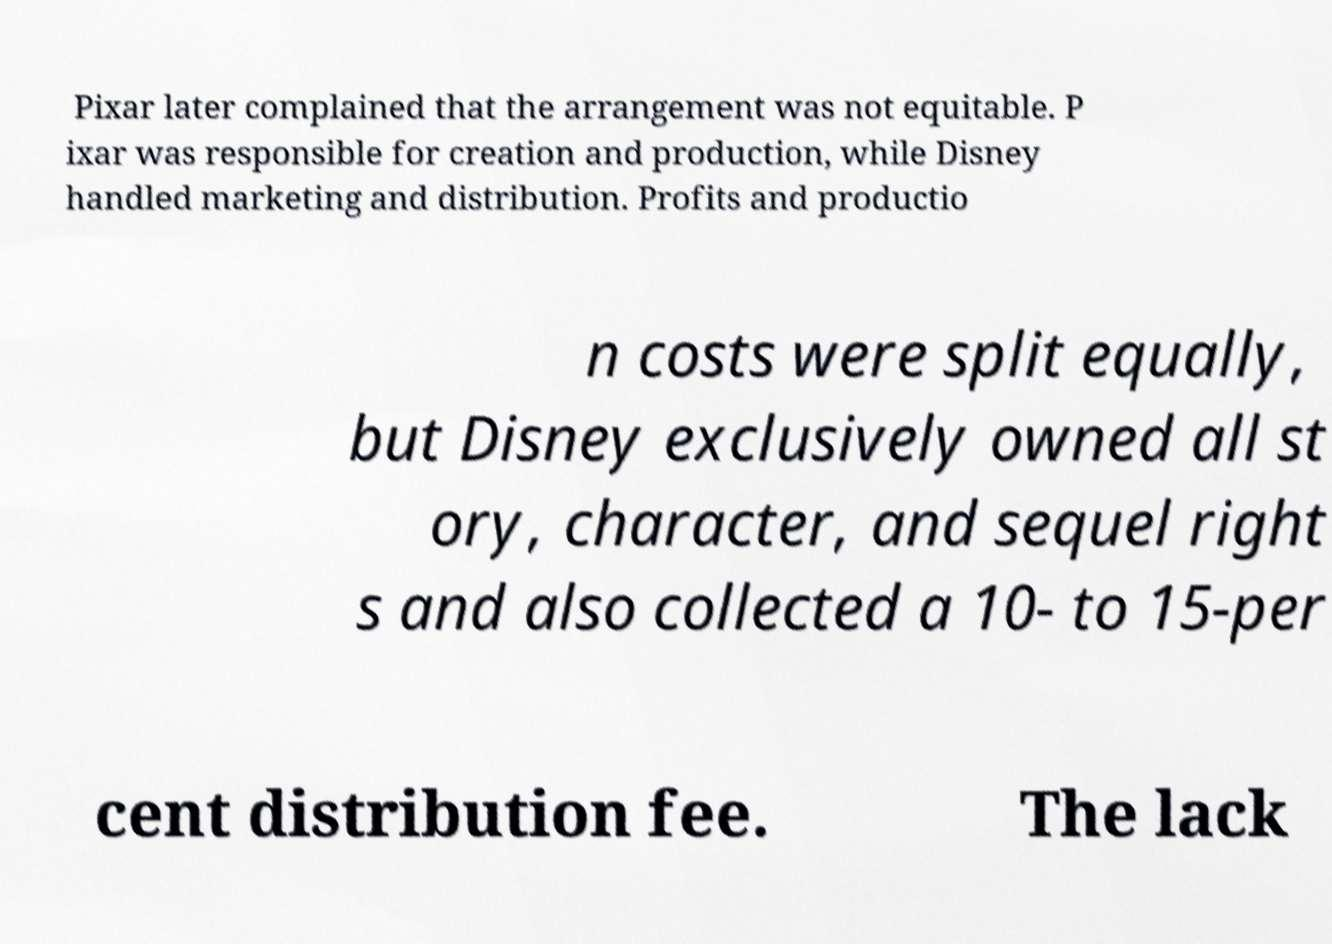Can you accurately transcribe the text from the provided image for me? Pixar later complained that the arrangement was not equitable. P ixar was responsible for creation and production, while Disney handled marketing and distribution. Profits and productio n costs were split equally, but Disney exclusively owned all st ory, character, and sequel right s and also collected a 10- to 15-per cent distribution fee. The lack 